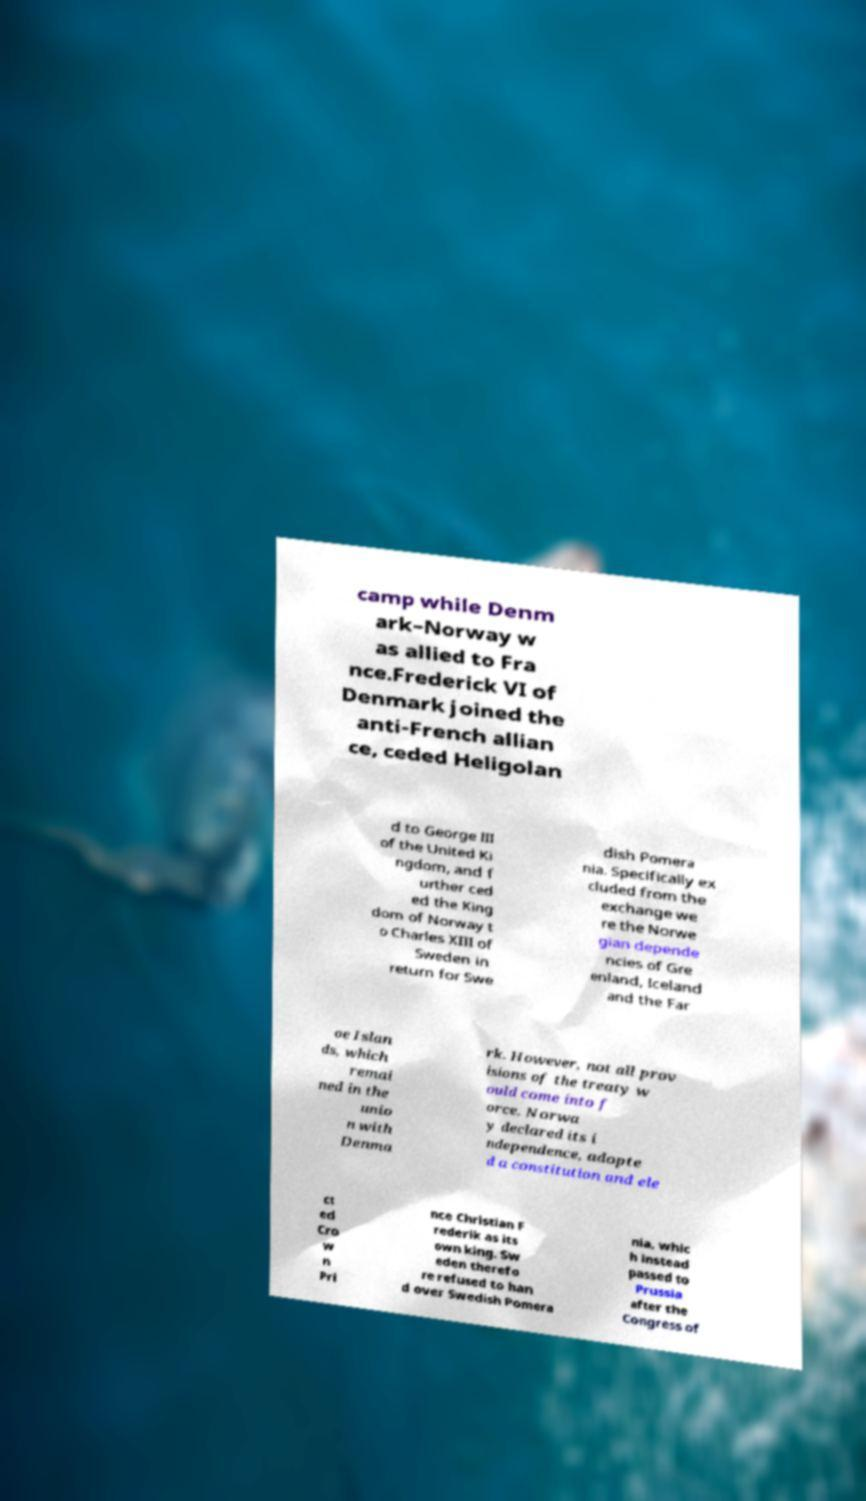Can you accurately transcribe the text from the provided image for me? camp while Denm ark–Norway w as allied to Fra nce.Frederick VI of Denmark joined the anti-French allian ce, ceded Heligolan d to George III of the United Ki ngdom, and f urther ced ed the King dom of Norway t o Charles XIII of Sweden in return for Swe dish Pomera nia. Specifically ex cluded from the exchange we re the Norwe gian depende ncies of Gre enland, Iceland and the Far oe Islan ds, which remai ned in the unio n with Denma rk. However, not all prov isions of the treaty w ould come into f orce. Norwa y declared its i ndependence, adopte d a constitution and ele ct ed Cro w n Pri nce Christian F rederik as its own king. Sw eden therefo re refused to han d over Swedish Pomera nia, whic h instead passed to Prussia after the Congress of 